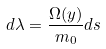Convert formula to latex. <formula><loc_0><loc_0><loc_500><loc_500>d \lambda = \frac { \Omega ( y ) } { m _ { 0 } } d s</formula> 